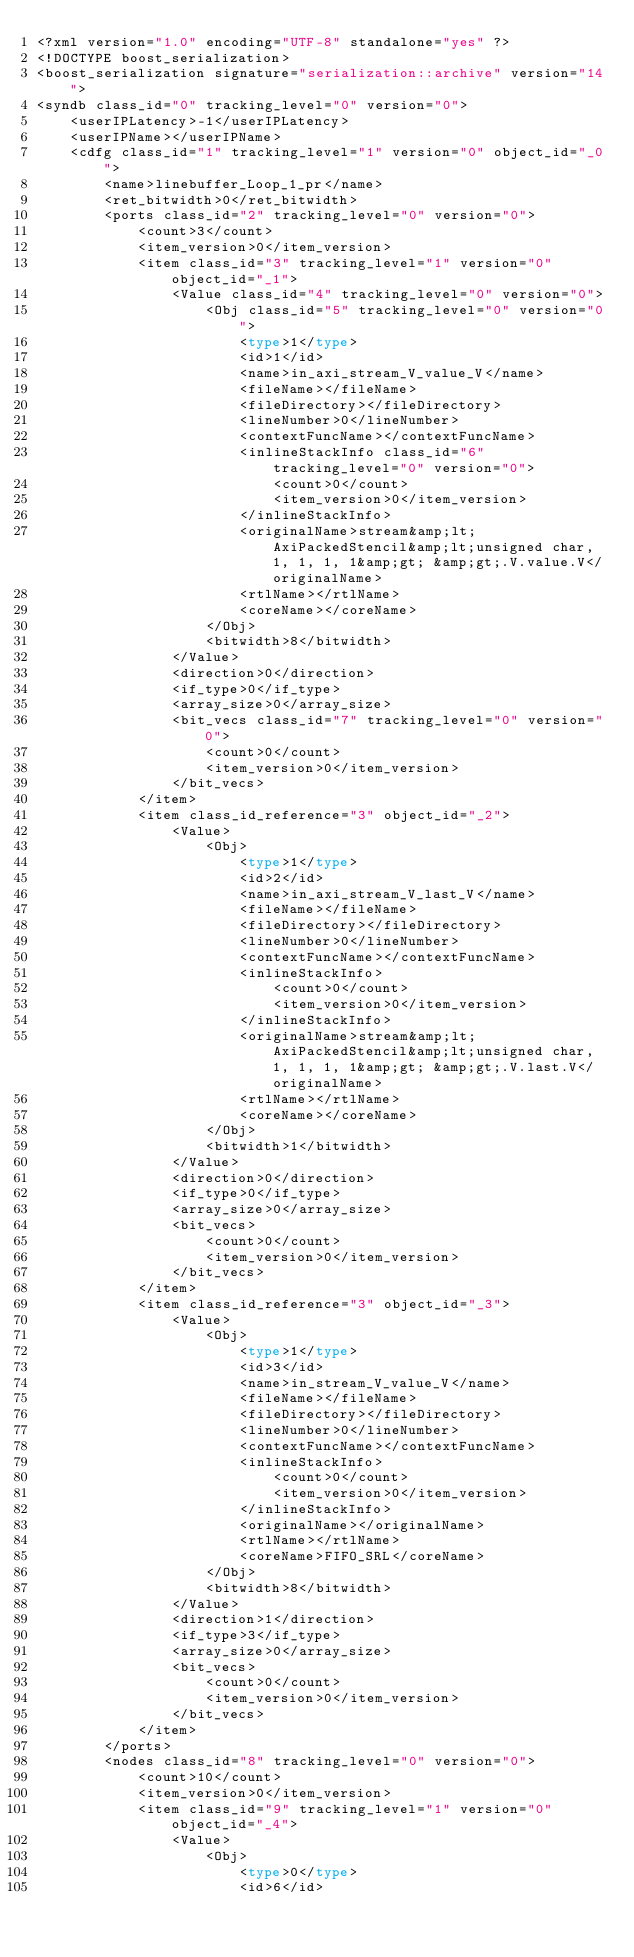Convert code to text. <code><loc_0><loc_0><loc_500><loc_500><_Ada_><?xml version="1.0" encoding="UTF-8" standalone="yes" ?>
<!DOCTYPE boost_serialization>
<boost_serialization signature="serialization::archive" version="14">
<syndb class_id="0" tracking_level="0" version="0">
	<userIPLatency>-1</userIPLatency>
	<userIPName></userIPName>
	<cdfg class_id="1" tracking_level="1" version="0" object_id="_0">
		<name>linebuffer_Loop_1_pr</name>
		<ret_bitwidth>0</ret_bitwidth>
		<ports class_id="2" tracking_level="0" version="0">
			<count>3</count>
			<item_version>0</item_version>
			<item class_id="3" tracking_level="1" version="0" object_id="_1">
				<Value class_id="4" tracking_level="0" version="0">
					<Obj class_id="5" tracking_level="0" version="0">
						<type>1</type>
						<id>1</id>
						<name>in_axi_stream_V_value_V</name>
						<fileName></fileName>
						<fileDirectory></fileDirectory>
						<lineNumber>0</lineNumber>
						<contextFuncName></contextFuncName>
						<inlineStackInfo class_id="6" tracking_level="0" version="0">
							<count>0</count>
							<item_version>0</item_version>
						</inlineStackInfo>
						<originalName>stream&amp;lt;AxiPackedStencil&amp;lt;unsigned char, 1, 1, 1, 1&amp;gt; &amp;gt;.V.value.V</originalName>
						<rtlName></rtlName>
						<coreName></coreName>
					</Obj>
					<bitwidth>8</bitwidth>
				</Value>
				<direction>0</direction>
				<if_type>0</if_type>
				<array_size>0</array_size>
				<bit_vecs class_id="7" tracking_level="0" version="0">
					<count>0</count>
					<item_version>0</item_version>
				</bit_vecs>
			</item>
			<item class_id_reference="3" object_id="_2">
				<Value>
					<Obj>
						<type>1</type>
						<id>2</id>
						<name>in_axi_stream_V_last_V</name>
						<fileName></fileName>
						<fileDirectory></fileDirectory>
						<lineNumber>0</lineNumber>
						<contextFuncName></contextFuncName>
						<inlineStackInfo>
							<count>0</count>
							<item_version>0</item_version>
						</inlineStackInfo>
						<originalName>stream&amp;lt;AxiPackedStencil&amp;lt;unsigned char, 1, 1, 1, 1&amp;gt; &amp;gt;.V.last.V</originalName>
						<rtlName></rtlName>
						<coreName></coreName>
					</Obj>
					<bitwidth>1</bitwidth>
				</Value>
				<direction>0</direction>
				<if_type>0</if_type>
				<array_size>0</array_size>
				<bit_vecs>
					<count>0</count>
					<item_version>0</item_version>
				</bit_vecs>
			</item>
			<item class_id_reference="3" object_id="_3">
				<Value>
					<Obj>
						<type>1</type>
						<id>3</id>
						<name>in_stream_V_value_V</name>
						<fileName></fileName>
						<fileDirectory></fileDirectory>
						<lineNumber>0</lineNumber>
						<contextFuncName></contextFuncName>
						<inlineStackInfo>
							<count>0</count>
							<item_version>0</item_version>
						</inlineStackInfo>
						<originalName></originalName>
						<rtlName></rtlName>
						<coreName>FIFO_SRL</coreName>
					</Obj>
					<bitwidth>8</bitwidth>
				</Value>
				<direction>1</direction>
				<if_type>3</if_type>
				<array_size>0</array_size>
				<bit_vecs>
					<count>0</count>
					<item_version>0</item_version>
				</bit_vecs>
			</item>
		</ports>
		<nodes class_id="8" tracking_level="0" version="0">
			<count>10</count>
			<item_version>0</item_version>
			<item class_id="9" tracking_level="1" version="0" object_id="_4">
				<Value>
					<Obj>
						<type>0</type>
						<id>6</id></code> 